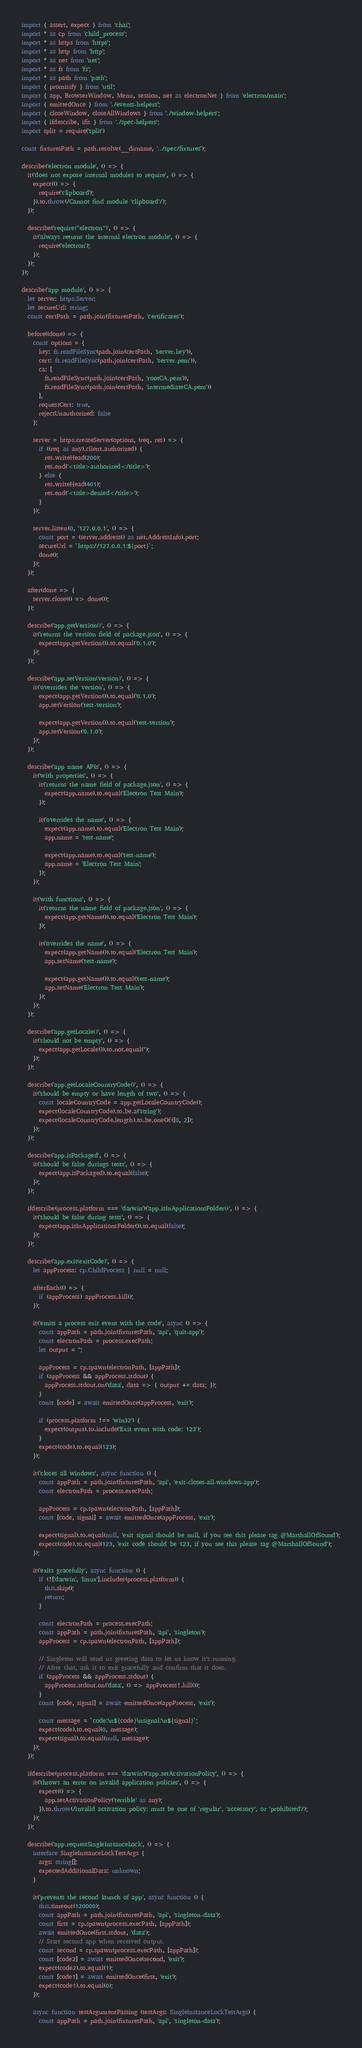<code> <loc_0><loc_0><loc_500><loc_500><_TypeScript_>import { assert, expect } from 'chai';
import * as cp from 'child_process';
import * as https from 'https';
import * as http from 'http';
import * as net from 'net';
import * as fs from 'fs';
import * as path from 'path';
import { promisify } from 'util';
import { app, BrowserWindow, Menu, session, net as electronNet } from 'electron/main';
import { emittedOnce } from './events-helpers';
import { closeWindow, closeAllWindows } from './window-helpers';
import { ifdescribe, ifit } from './spec-helpers';
import split = require('split')

const fixturesPath = path.resolve(__dirname, '../spec/fixtures');

describe('electron module', () => {
  it('does not expose internal modules to require', () => {
    expect(() => {
      require('clipboard');
    }).to.throw(/Cannot find module 'clipboard'/);
  });

  describe('require("electron")', () => {
    it('always returns the internal electron module', () => {
      require('electron');
    });
  });
});

describe('app module', () => {
  let server: https.Server;
  let secureUrl: string;
  const certPath = path.join(fixturesPath, 'certificates');

  before((done) => {
    const options = {
      key: fs.readFileSync(path.join(certPath, 'server.key')),
      cert: fs.readFileSync(path.join(certPath, 'server.pem')),
      ca: [
        fs.readFileSync(path.join(certPath, 'rootCA.pem')),
        fs.readFileSync(path.join(certPath, 'intermediateCA.pem'))
      ],
      requestCert: true,
      rejectUnauthorized: false
    };

    server = https.createServer(options, (req, res) => {
      if ((req as any).client.authorized) {
        res.writeHead(200);
        res.end('<title>authorized</title>');
      } else {
        res.writeHead(401);
        res.end('<title>denied</title>');
      }
    });

    server.listen(0, '127.0.0.1', () => {
      const port = (server.address() as net.AddressInfo).port;
      secureUrl = `https://127.0.0.1:${port}`;
      done();
    });
  });

  after(done => {
    server.close(() => done());
  });

  describe('app.getVersion()', () => {
    it('returns the version field of package.json', () => {
      expect(app.getVersion()).to.equal('0.1.0');
    });
  });

  describe('app.setVersion(version)', () => {
    it('overrides the version', () => {
      expect(app.getVersion()).to.equal('0.1.0');
      app.setVersion('test-version');

      expect(app.getVersion()).to.equal('test-version');
      app.setVersion('0.1.0');
    });
  });

  describe('app name APIs', () => {
    it('with properties', () => {
      it('returns the name field of package.json', () => {
        expect(app.name).to.equal('Electron Test Main');
      });

      it('overrides the name', () => {
        expect(app.name).to.equal('Electron Test Main');
        app.name = 'test-name';

        expect(app.name).to.equal('test-name');
        app.name = 'Electron Test Main';
      });
    });

    it('with functions', () => {
      it('returns the name field of package.json', () => {
        expect(app.getName()).to.equal('Electron Test Main');
      });

      it('overrides the name', () => {
        expect(app.getName()).to.equal('Electron Test Main');
        app.setName('test-name');

        expect(app.getName()).to.equal('test-name');
        app.setName('Electron Test Main');
      });
    });
  });

  describe('app.getLocale()', () => {
    it('should not be empty', () => {
      expect(app.getLocale()).to.not.equal('');
    });
  });

  describe('app.getLocaleCountryCode()', () => {
    it('should be empty or have length of two', () => {
      const localeCountryCode = app.getLocaleCountryCode();
      expect(localeCountryCode).to.be.a('string');
      expect(localeCountryCode.length).to.be.oneOf([0, 2]);
    });
  });

  describe('app.isPackaged', () => {
    it('should be false durings tests', () => {
      expect(app.isPackaged).to.equal(false);
    });
  });

  ifdescribe(process.platform === 'darwin')('app.isInApplicationsFolder()', () => {
    it('should be false during tests', () => {
      expect(app.isInApplicationsFolder()).to.equal(false);
    });
  });

  describe('app.exit(exitCode)', () => {
    let appProcess: cp.ChildProcess | null = null;

    afterEach(() => {
      if (appProcess) appProcess.kill();
    });

    it('emits a process exit event with the code', async () => {
      const appPath = path.join(fixturesPath, 'api', 'quit-app');
      const electronPath = process.execPath;
      let output = '';

      appProcess = cp.spawn(electronPath, [appPath]);
      if (appProcess && appProcess.stdout) {
        appProcess.stdout.on('data', data => { output += data; });
      }
      const [code] = await emittedOnce(appProcess, 'exit');

      if (process.platform !== 'win32') {
        expect(output).to.include('Exit event with code: 123');
      }
      expect(code).to.equal(123);
    });

    it('closes all windows', async function () {
      const appPath = path.join(fixturesPath, 'api', 'exit-closes-all-windows-app');
      const electronPath = process.execPath;

      appProcess = cp.spawn(electronPath, [appPath]);
      const [code, signal] = await emittedOnce(appProcess, 'exit');

      expect(signal).to.equal(null, 'exit signal should be null, if you see this please tag @MarshallOfSound');
      expect(code).to.equal(123, 'exit code should be 123, if you see this please tag @MarshallOfSound');
    });

    it('exits gracefully', async function () {
      if (!['darwin', 'linux'].includes(process.platform)) {
        this.skip();
        return;
      }

      const electronPath = process.execPath;
      const appPath = path.join(fixturesPath, 'api', 'singleton');
      appProcess = cp.spawn(electronPath, [appPath]);

      // Singleton will send us greeting data to let us know it's running.
      // After that, ask it to exit gracefully and confirm that it does.
      if (appProcess && appProcess.stdout) {
        appProcess.stdout.on('data', () => appProcess!.kill());
      }
      const [code, signal] = await emittedOnce(appProcess, 'exit');

      const message = `code:\n${code}\nsignal:\n${signal}`;
      expect(code).to.equal(0, message);
      expect(signal).to.equal(null, message);
    });
  });

  ifdescribe(process.platform === 'darwin')('app.setActivationPolicy', () => {
    it('throws an error on invalid application policies', () => {
      expect(() => {
        app.setActivationPolicy('terrible' as any);
      }).to.throw(/Invalid activation policy: must be one of 'regular', 'accessory', or 'prohibited'/);
    });
  });

  describe('app.requestSingleInstanceLock', () => {
    interface SingleInstanceLockTestArgs {
      args: string[];
      expectedAdditionalData: unknown;
    }

    it('prevents the second launch of app', async function () {
      this.timeout(120000);
      const appPath = path.join(fixturesPath, 'api', 'singleton-data');
      const first = cp.spawn(process.execPath, [appPath]);
      await emittedOnce(first.stdout, 'data');
      // Start second app when received output.
      const second = cp.spawn(process.execPath, [appPath]);
      const [code2] = await emittedOnce(second, 'exit');
      expect(code2).to.equal(1);
      const [code1] = await emittedOnce(first, 'exit');
      expect(code1).to.equal(0);
    });

    async function testArgumentPassing (testArgs: SingleInstanceLockTestArgs) {
      const appPath = path.join(fixturesPath, 'api', 'singleton-data');</code> 